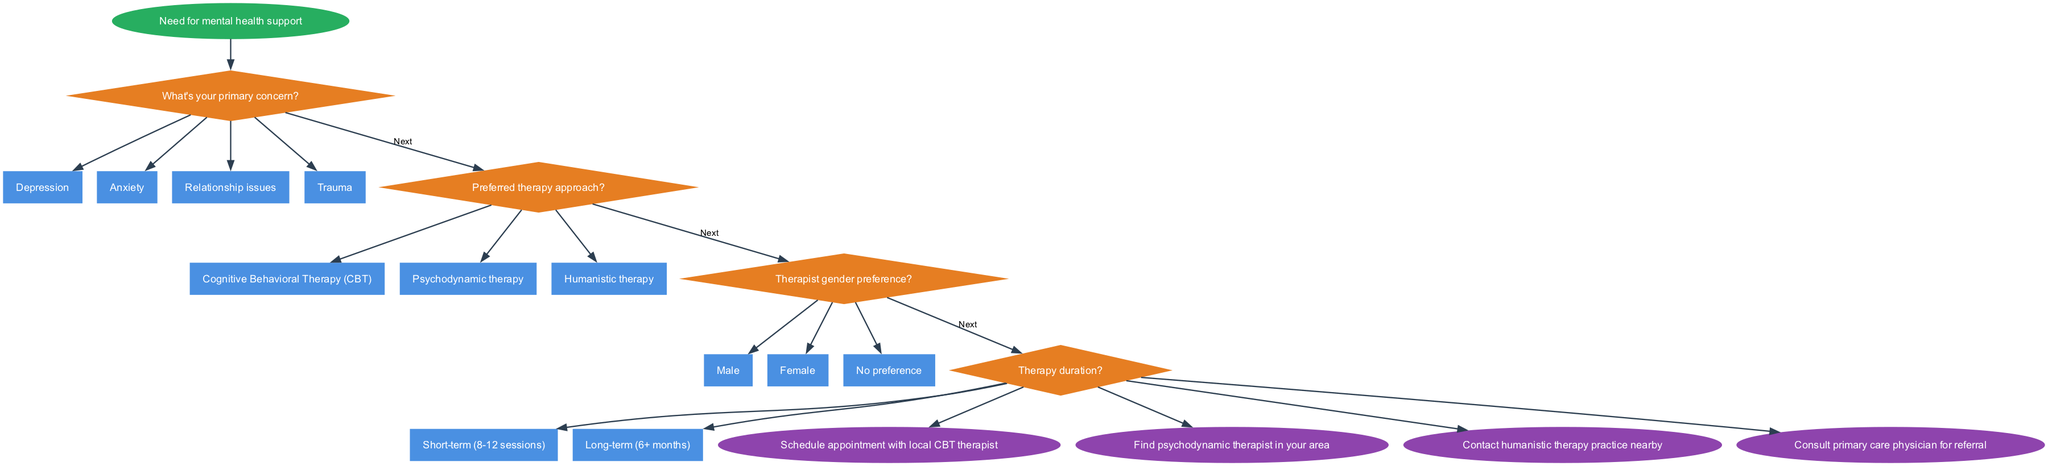What's the starting point of the flowchart? The diagram begins at the node labeled "Need for mental health support." This is indicated as the starting point in an oval shape at the top of the chart.
Answer: Need for mental health support How many primary concerns are presented in the decision nodes? There are four primary concerns listed in the first decision node regarding the type of therapy needed: Depression, Anxiety, Relationship issues, and Trauma. This counts the options in that decision node.
Answer: 4 What is the endpoint if a person prefers Psychodynamic therapy? According to the diagram, if a person chooses Psychodynamic therapy, they will end up at the endpoint labeled "Find psychodynamic therapist in your area." This endpoint is linked directly to the last decision node.
Answer: Find psychodynamic therapist in your area What are the options listed under the therapy approach decision node? There are three options provided in the therapy approach decision node: Cognitive Behavioral Therapy (CBT), Psychodynamic therapy, and Humanistic therapy. This can be traced directly from the options listed in that decision node.
Answer: Cognitive Behavioral Therapy (CBT), Psychodynamic therapy, Humanistic therapy Which therapy option leads to the endpoint of "Consult primary care physician for referral"? Following the flowchart, if the user indicates a preference for short-term therapy, they will then reach the endpoint "Consult primary care physician for referral." This follows the reasoning through the decision nodes about therapy duration.
Answer: Consult primary care physician for referral If the user has no gender preference for their therapist, which options can they select next? From the decision related to therapist gender preference, if the user has no preference, they can select any of the therapy options that follow, including CB therapy or Humanistic therapy. This is demonstrated by the connections from the gender preference decision node.
Answer: Any of the therapy options 